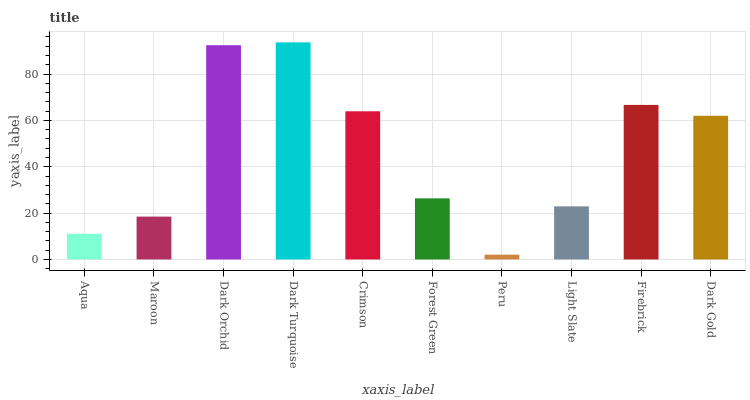Is Peru the minimum?
Answer yes or no. Yes. Is Dark Turquoise the maximum?
Answer yes or no. Yes. Is Maroon the minimum?
Answer yes or no. No. Is Maroon the maximum?
Answer yes or no. No. Is Maroon greater than Aqua?
Answer yes or no. Yes. Is Aqua less than Maroon?
Answer yes or no. Yes. Is Aqua greater than Maroon?
Answer yes or no. No. Is Maroon less than Aqua?
Answer yes or no. No. Is Dark Gold the high median?
Answer yes or no. Yes. Is Forest Green the low median?
Answer yes or no. Yes. Is Maroon the high median?
Answer yes or no. No. Is Dark Turquoise the low median?
Answer yes or no. No. 